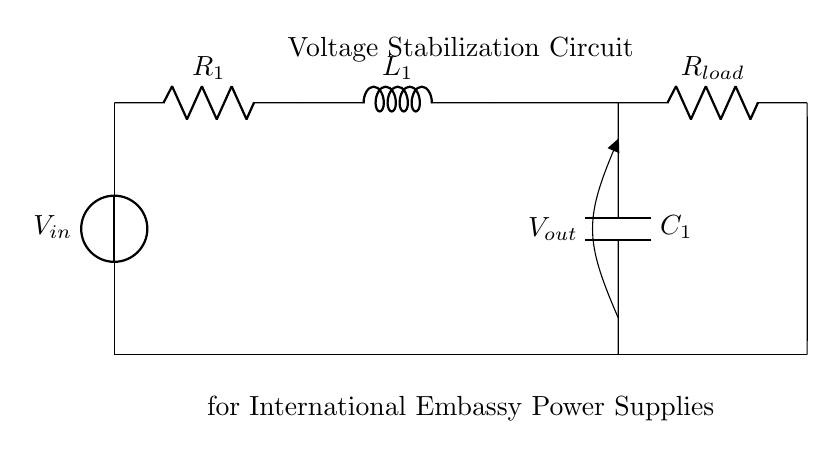What is the input voltage of the circuit? The input voltage, denoted as V_in, is indicated at the source in the circuit. The exact value would need to be specified, but it is the first point in the circuit where voltage is applied.
Answer: V_in What is the purpose of the capacitor in this circuit? The capacitor, labeled C_1, is used for voltage stabilization by storing charge and releasing it when needed, which helps to smooth out fluctuations in voltage across the load.
Answer: Voltage stabilization Which component provides resistance to the current flow? The resistor R_1 is the component that opposes current flow, and it is specifically designed to limit the amount of current based on its resistance value defined by Ohm's law.
Answer: R_1 What is the total impedance of this series RLC circuit? To calculate the total impedance in a series RLC circuit, one must consider the resistance, inductance, and capacitance values that affect the circuit's overall impedance, formulated as Z_total = R + j(ωL - 1/ωC). Since the values are not provided in the diagram, a numerical answer cannot be given without additional data.
Answer: Depends on R, L, and C values How does the inductor affect the circuit behavior? The inductor L_1 stores energy in a magnetic field when current flows through it, which plays a crucial role in determining the circuit's response to changes in voltage and influences the phase relationship between current and voltage in AC applications, effectively affecting the circuit's behavior in stabilizing voltage.
Answer: Energy storage What is the load resistance in this circuit? The load resistor is labeled R_load and is connected in parallel with the capacitor, providing a pathway for current and represents the load the circuit has to support, specifically designed based on the requirements of the embassy power supplies.
Answer: R_load What does the output voltage (V_out) represent in this circuit? V_out is the voltage level measured across the load resistor and is crucial for ensuring that the power supplied to the embassy's equipment is stable and meets operational needs; it is influenced by the behavior of the RLC components.
Answer: V_out 